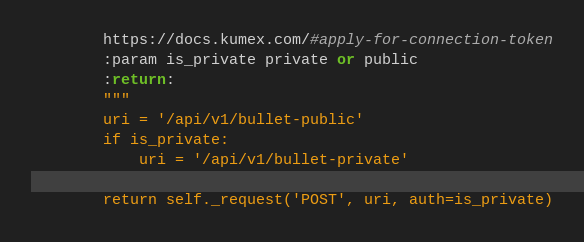<code> <loc_0><loc_0><loc_500><loc_500><_Python_>        https://docs.kumex.com/#apply-for-connection-token
        :param is_private private or public
        :return:
        """
        uri = '/api/v1/bullet-public'
        if is_private:
            uri = '/api/v1/bullet-private'

        return self._request('POST', uri, auth=is_private)


</code> 